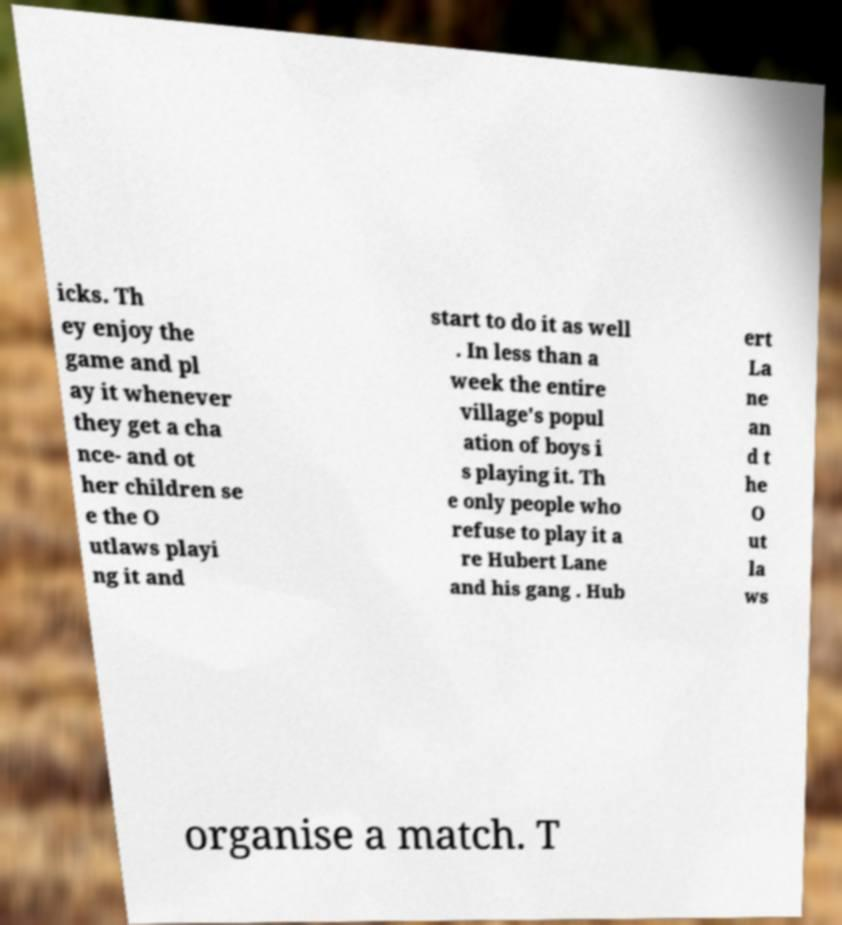Could you extract and type out the text from this image? icks. Th ey enjoy the game and pl ay it whenever they get a cha nce- and ot her children se e the O utlaws playi ng it and start to do it as well . In less than a week the entire village's popul ation of boys i s playing it. Th e only people who refuse to play it a re Hubert Lane and his gang . Hub ert La ne an d t he O ut la ws organise a match. T 